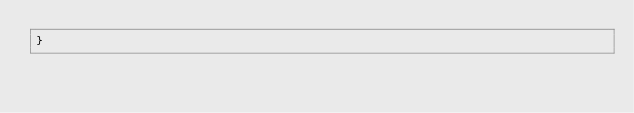<code> <loc_0><loc_0><loc_500><loc_500><_C++_>}
</code> 